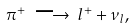<formula> <loc_0><loc_0><loc_500><loc_500>\pi ^ { + } \, \longrightarrow \, l ^ { + } + \nu _ { l } ,</formula> 